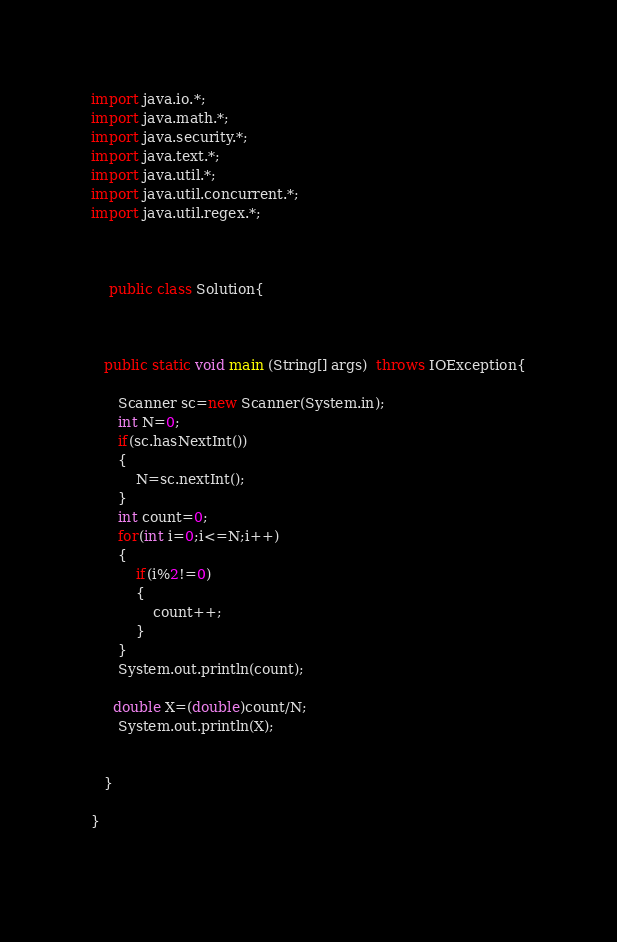Convert code to text. <code><loc_0><loc_0><loc_500><loc_500><_Java_>import java.io.*;
import java.math.*;
import java.security.*;
import java.text.*;
import java.util.*;
import java.util.concurrent.*;
import java.util.regex.*;


    
    public class Solution{
        
        

   public static void main (String[] args)  throws IOException{

      Scanner sc=new Scanner(System.in);
      int N=0;
      if(sc.hasNextInt())
      {
          N=sc.nextInt();
      }
      int count=0;
      for(int i=0;i<=N;i++)
      {
          if(i%2!=0)
          {
              count++;
          }
      }
      System.out.println(count);
     
     double X=(double)count/N;
      System.out.println(X);
        
       
   }
   
}
  </code> 